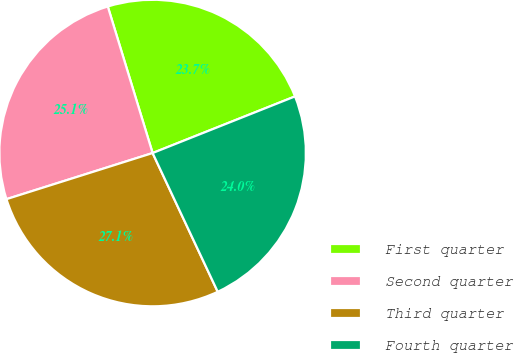Convert chart. <chart><loc_0><loc_0><loc_500><loc_500><pie_chart><fcel>First quarter<fcel>Second quarter<fcel>Third quarter<fcel>Fourth quarter<nl><fcel>23.7%<fcel>25.14%<fcel>27.12%<fcel>24.04%<nl></chart> 